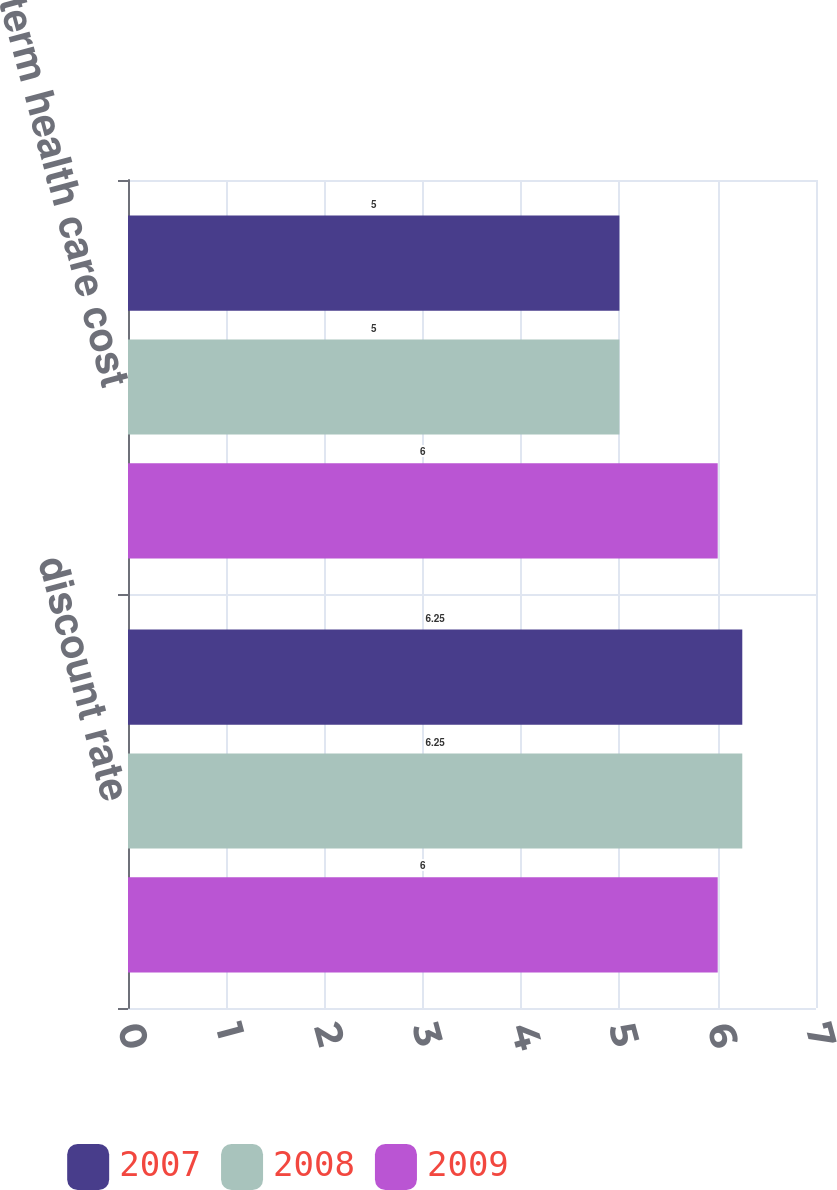Convert chart to OTSL. <chart><loc_0><loc_0><loc_500><loc_500><stacked_bar_chart><ecel><fcel>discount rate<fcel>long-term health care cost<nl><fcel>2007<fcel>6.25<fcel>5<nl><fcel>2008<fcel>6.25<fcel>5<nl><fcel>2009<fcel>6<fcel>6<nl></chart> 